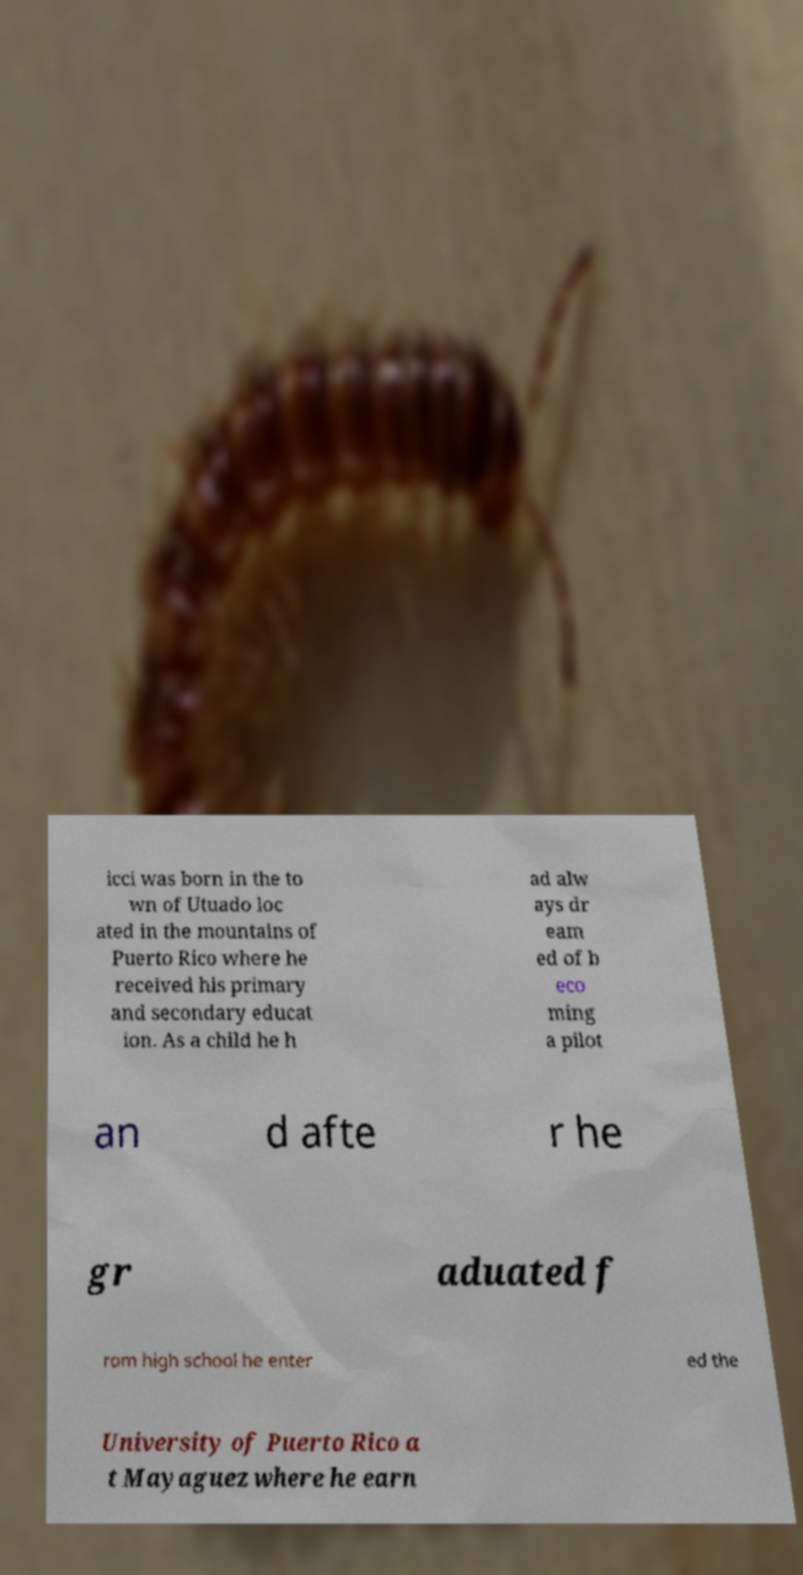I need the written content from this picture converted into text. Can you do that? icci was born in the to wn of Utuado loc ated in the mountains of Puerto Rico where he received his primary and secondary educat ion. As a child he h ad alw ays dr eam ed of b eco ming a pilot an d afte r he gr aduated f rom high school he enter ed the University of Puerto Rico a t Mayaguez where he earn 